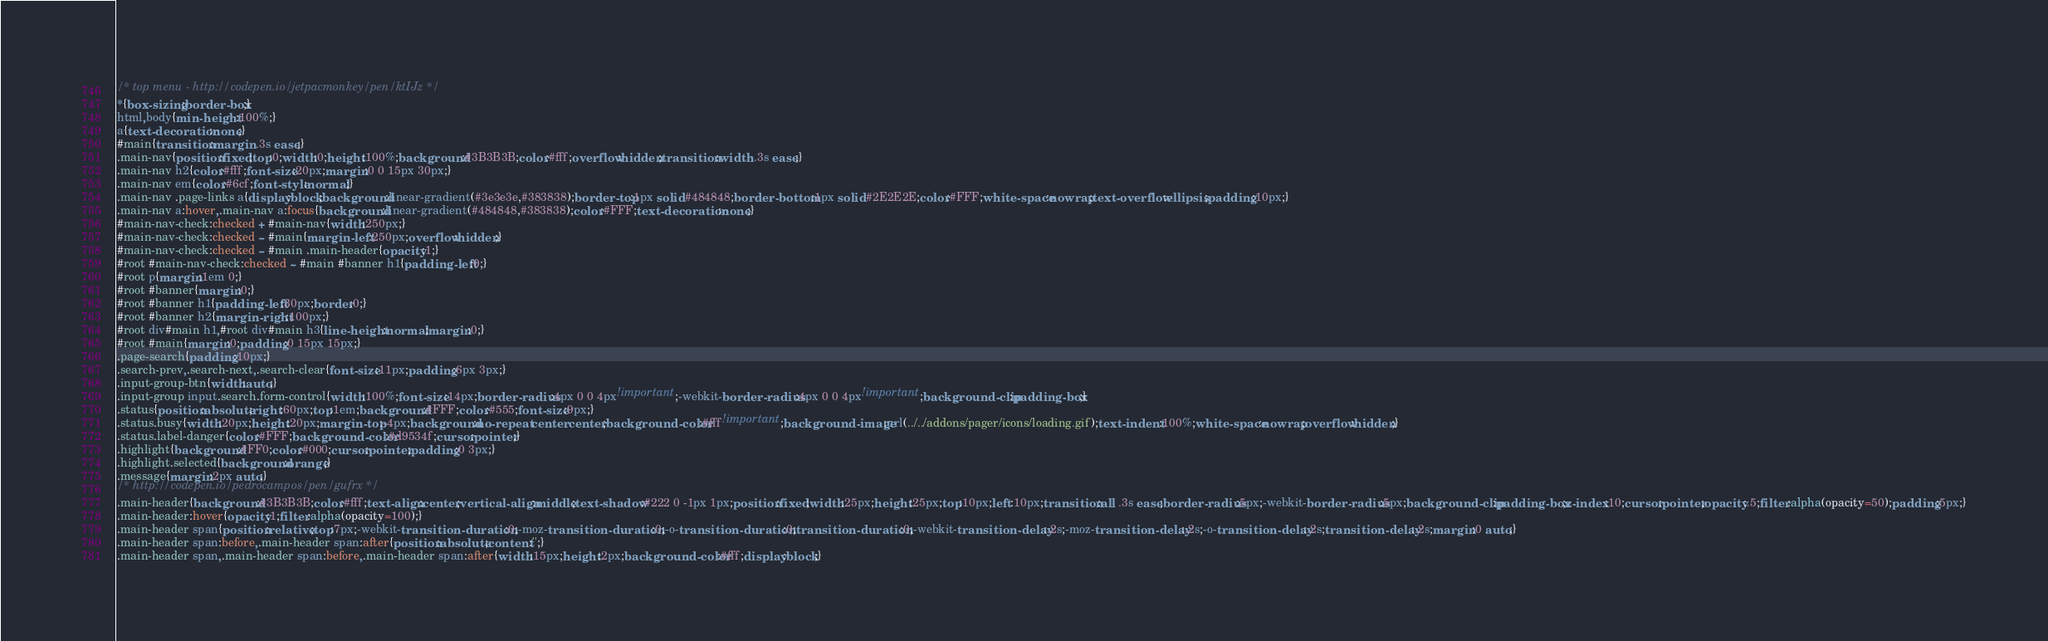Convert code to text. <code><loc_0><loc_0><loc_500><loc_500><_CSS_>/* top menu - http://codepen.io/jetpacmonkey/pen/ktIJz */
*{box-sizing:border-box;}
html,body{min-height:100%;}
a{text-decoration:none;}
#main{transition:margin .3s ease;}
.main-nav{position:fixed;top:0;width:0;height:100%;background:#3B3B3B;color:#fff;overflow:hidden;transition:width .3s ease;}
.main-nav h2{color:#fff;font-size:20px;margin:0 0 15px 30px;}
.main-nav em{color:#6cf;font-style:normal;}
.main-nav .page-links a{display:block;background:linear-gradient(#3e3e3e,#383838);border-top:1px solid #484848;border-bottom:1px solid #2E2E2E;color:#FFF;white-space:nowrap;text-overflow:ellipsis;padding:10px;}
.main-nav a:hover,.main-nav a:focus{background:linear-gradient(#484848,#383838);color:#FFF;text-decoration:none;}
#main-nav-check:checked + #main-nav{width:250px;}
#main-nav-check:checked ~ #main{margin-left:250px;overflow:hidden;}
#main-nav-check:checked ~ #main .main-header{opacity:1;}
#root #main-nav-check:checked ~ #main #banner h1{padding-left:0;}
#root p{margin:1em 0;}
#root #banner{margin:0;}
#root #banner h1{padding-left:30px;border:0;}
#root #banner h2{margin-right:100px;}
#root div#main h1,#root div#main h3{line-height:normal;margin:0;}
#root #main{margin:0;padding:0 15px 15px;}
.page-search{padding:10px;}
.search-prev,.search-next,.search-clear{font-size:11px;padding:6px 3px;}
.input-group-btn{width:auto;}
.input-group input.search.form-control{width:100%;font-size:14px;border-radius:4px 0 0 4px!important;-webkit-border-radius:4px 0 0 4px!important;background-clip:padding-box;}
.status{position:absolute;right:60px;top:1em;background:#FFF;color:#555;font-size:9px;}
.status.busy{width:20px;height:20px;margin-top:-4px;background:no-repeat center center;background-color:#fff!important;background-image:url(../../addons/pager/icons/loading.gif);text-indent:100%;white-space:nowrap;overflow:hidden;}
.status.label-danger{color:#FFF;background-color:#d9534f;cursor:pointer;}
.highlight{background:#FF0;color:#000;cursor:pointer;padding:0 3px;}
.highlight.selected{background:orange;}
.message{margin:2px auto;}
/* http://codepen.io/pedrocampos/pen/gufrx */
.main-header{background:#3B3B3B;color:#fff;text-align:center;vertical-align:middle;text-shadow:#222 0 -1px 1px;position:fixed;width:25px;height:25px;top:10px;left:10px;transition:all .3s ease;border-radius:5px;-webkit-border-radius:5px;background-clip:padding-box;z-index:10;cursor:pointer;opacity:.5;filter:alpha(opacity=50);padding:5px;}
.main-header:hover{opacity:1;filter:alpha(opacity=100);}
.main-header span{position:relative;top:7px;-webkit-transition-duration:0;-moz-transition-duration:0;-o-transition-duration:0;transition-duration:0;-webkit-transition-delay:.2s;-moz-transition-delay:.2s;-o-transition-delay:.2s;transition-delay:.2s;margin:0 auto;}
.main-header span:before,.main-header span:after{position:absolute;content:'';}
.main-header span,.main-header span:before,.main-header span:after{width:15px;height:2px;background-color:#fff;display:block;}</code> 